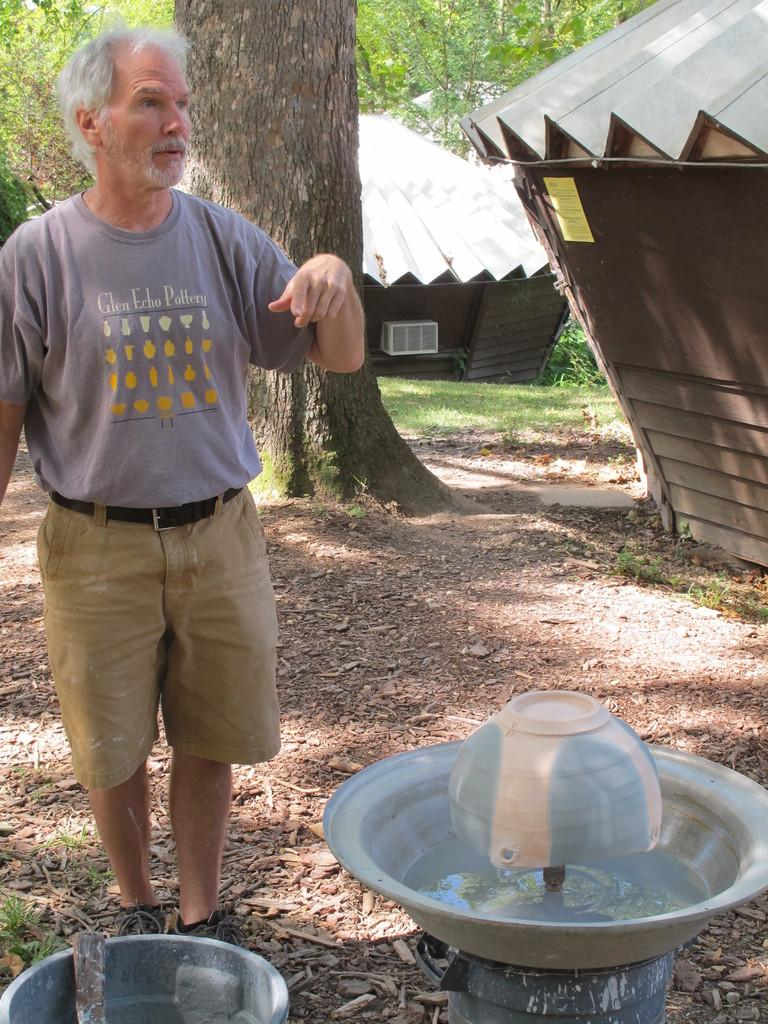<image>
Create a compact narrative representing the image presented. A man with a grey shirt for glen echo pottery standing behind a bird bath 